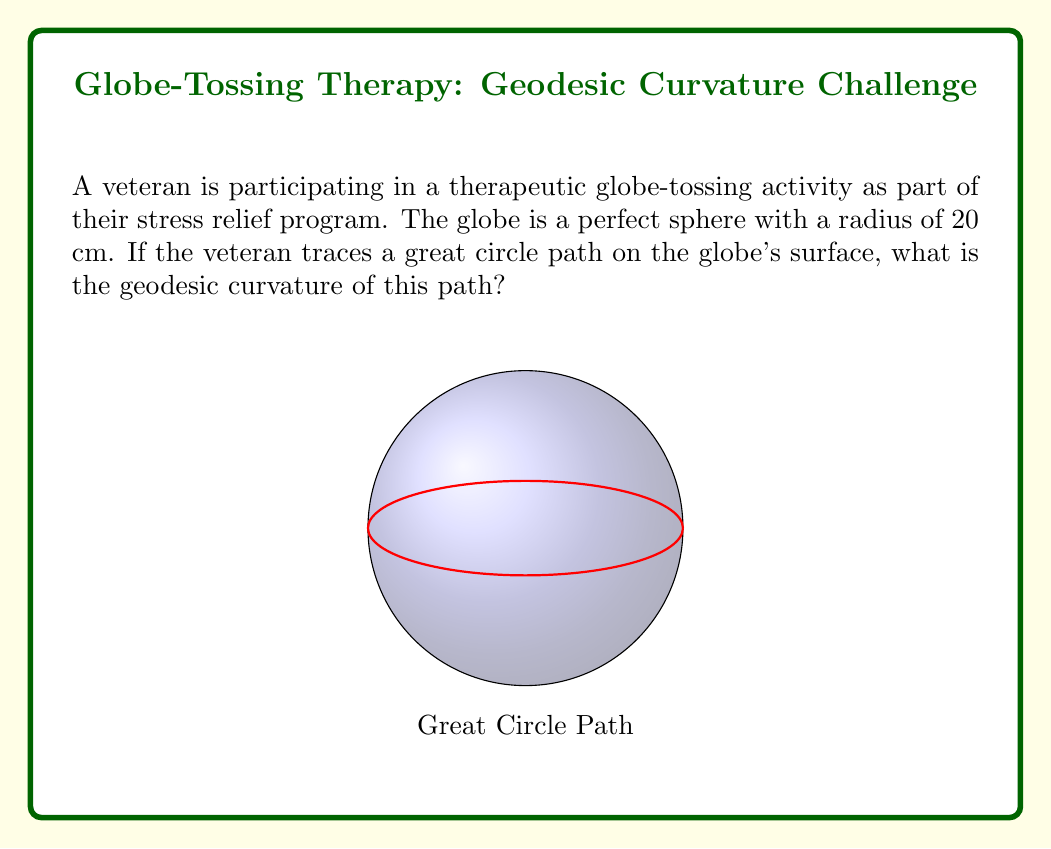Give your solution to this math problem. Let's approach this step-by-step:

1) First, recall that a geodesic is the shortest path between two points on a curved surface. On a sphere, geodesics are great circles.

2) The geodesic curvature of a curve on a surface measures how much the curve deviates from being a geodesic. Since we're given that the path is a great circle, which is already a geodesic, we know that it doesn't deviate at all.

3) Mathematically, the geodesic curvature $\kappa_g$ of a geodesic on any surface is always zero:

   $$\kappa_g = 0$$

4) This is true regardless of the radius of the sphere or any other parameters of the surface.

5) To understand why, consider that the geodesic curvature is the component of the curve's curvature that is tangent to the surface. For a great circle on a sphere, all of its curvature is directed inward, perpendicular to the surface, leaving no tangential component.

6) While the total curvature of the great circle path is not zero (it's actually $\frac{1}{R}$ where R is the radius of the sphere), its geodesic curvature specifically is zero.

Therefore, the geodesic curvature of the veteran's great circle path on the globe is zero, regardless of the globe's size or the specific path chosen (as long as it's a great circle).
Answer: $\kappa_g = 0$ 